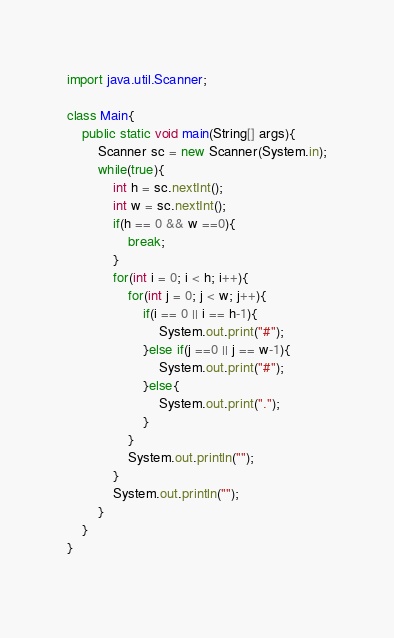Convert code to text. <code><loc_0><loc_0><loc_500><loc_500><_Java_>import java.util.Scanner;

class Main{
    public static void main(String[] args){
        Scanner sc = new Scanner(System.in);
        while(true){
            int h = sc.nextInt();
            int w = sc.nextInt();
            if(h == 0 && w ==0){
                break;
            }
            for(int i = 0; i < h; i++){
                for(int j = 0; j < w; j++){
                    if(i == 0 || i == h-1){
                        System.out.print("#");
                    }else if(j ==0 || j == w-1){
                        System.out.print("#");
                    }else{
                        System.out.print(".");
                    }
                }
                System.out.println("");
            }
            System.out.println("");
        }
    }
}
                  

</code> 